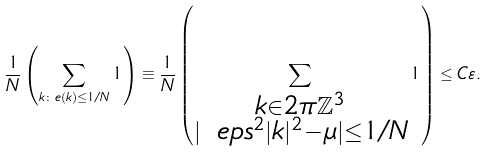Convert formula to latex. <formula><loc_0><loc_0><loc_500><loc_500>\frac { 1 } { N } \left ( \sum _ { k \colon e ( k ) \leq 1 / N } 1 \right ) \equiv \frac { 1 } { N } \left ( \sum _ { \substack { k \in 2 \pi \mathbb { Z } ^ { 3 } \\ | \ e p s ^ { 2 } | k | ^ { 2 } - \mu | \leq 1 / N } } 1 \right ) \leq C \varepsilon .</formula> 